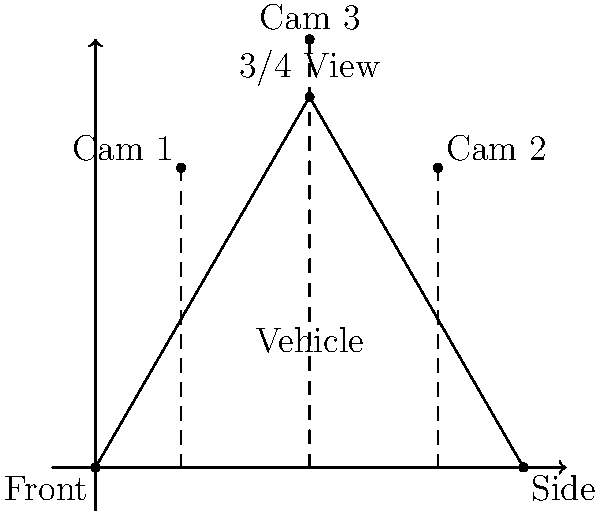Based on the diagram showing different camera angles for capturing a vehicle's exterior, which position is best suited for showcasing the vehicle's overall design and proportions in a single shot? To determine the best camera position for showcasing a vehicle's overall design and proportions, let's analyze each camera position:

1. Cam 1: This position represents a front-quarter view, slightly angled towards the front of the vehicle. While it shows some of the front and side, it doesn't provide a comprehensive view of the vehicle's proportions.

2. Cam 2: This position represents a rear-quarter view, angled towards the back of the vehicle. Similar to Cam 1, it shows some of the rear and side but doesn't offer a complete view of the vehicle's design.

3. Cam 3: This position represents the 3/4 view, which is positioned at a 45-degree angle to the vehicle's centerline. This angle is optimal for several reasons:

   a) It shows three sides of the vehicle simultaneously: the front, side, and top.
   b) It provides depth and dimensionality to the image, showcasing the vehicle's curves and lines.
   c) It allows viewers to see both the front and side design elements in a single shot.
   d) This angle minimizes perspective distortion, presenting the vehicle's proportions accurately.

The 3/4 view (Cam 3) is widely used in automotive photography and videography because it offers the most comprehensive and flattering view of a vehicle's design. It balances the vehicle's various design elements and gives potential customers a good overall impression of the car's aesthetics and proportions.
Answer: Cam 3 (3/4 view) 